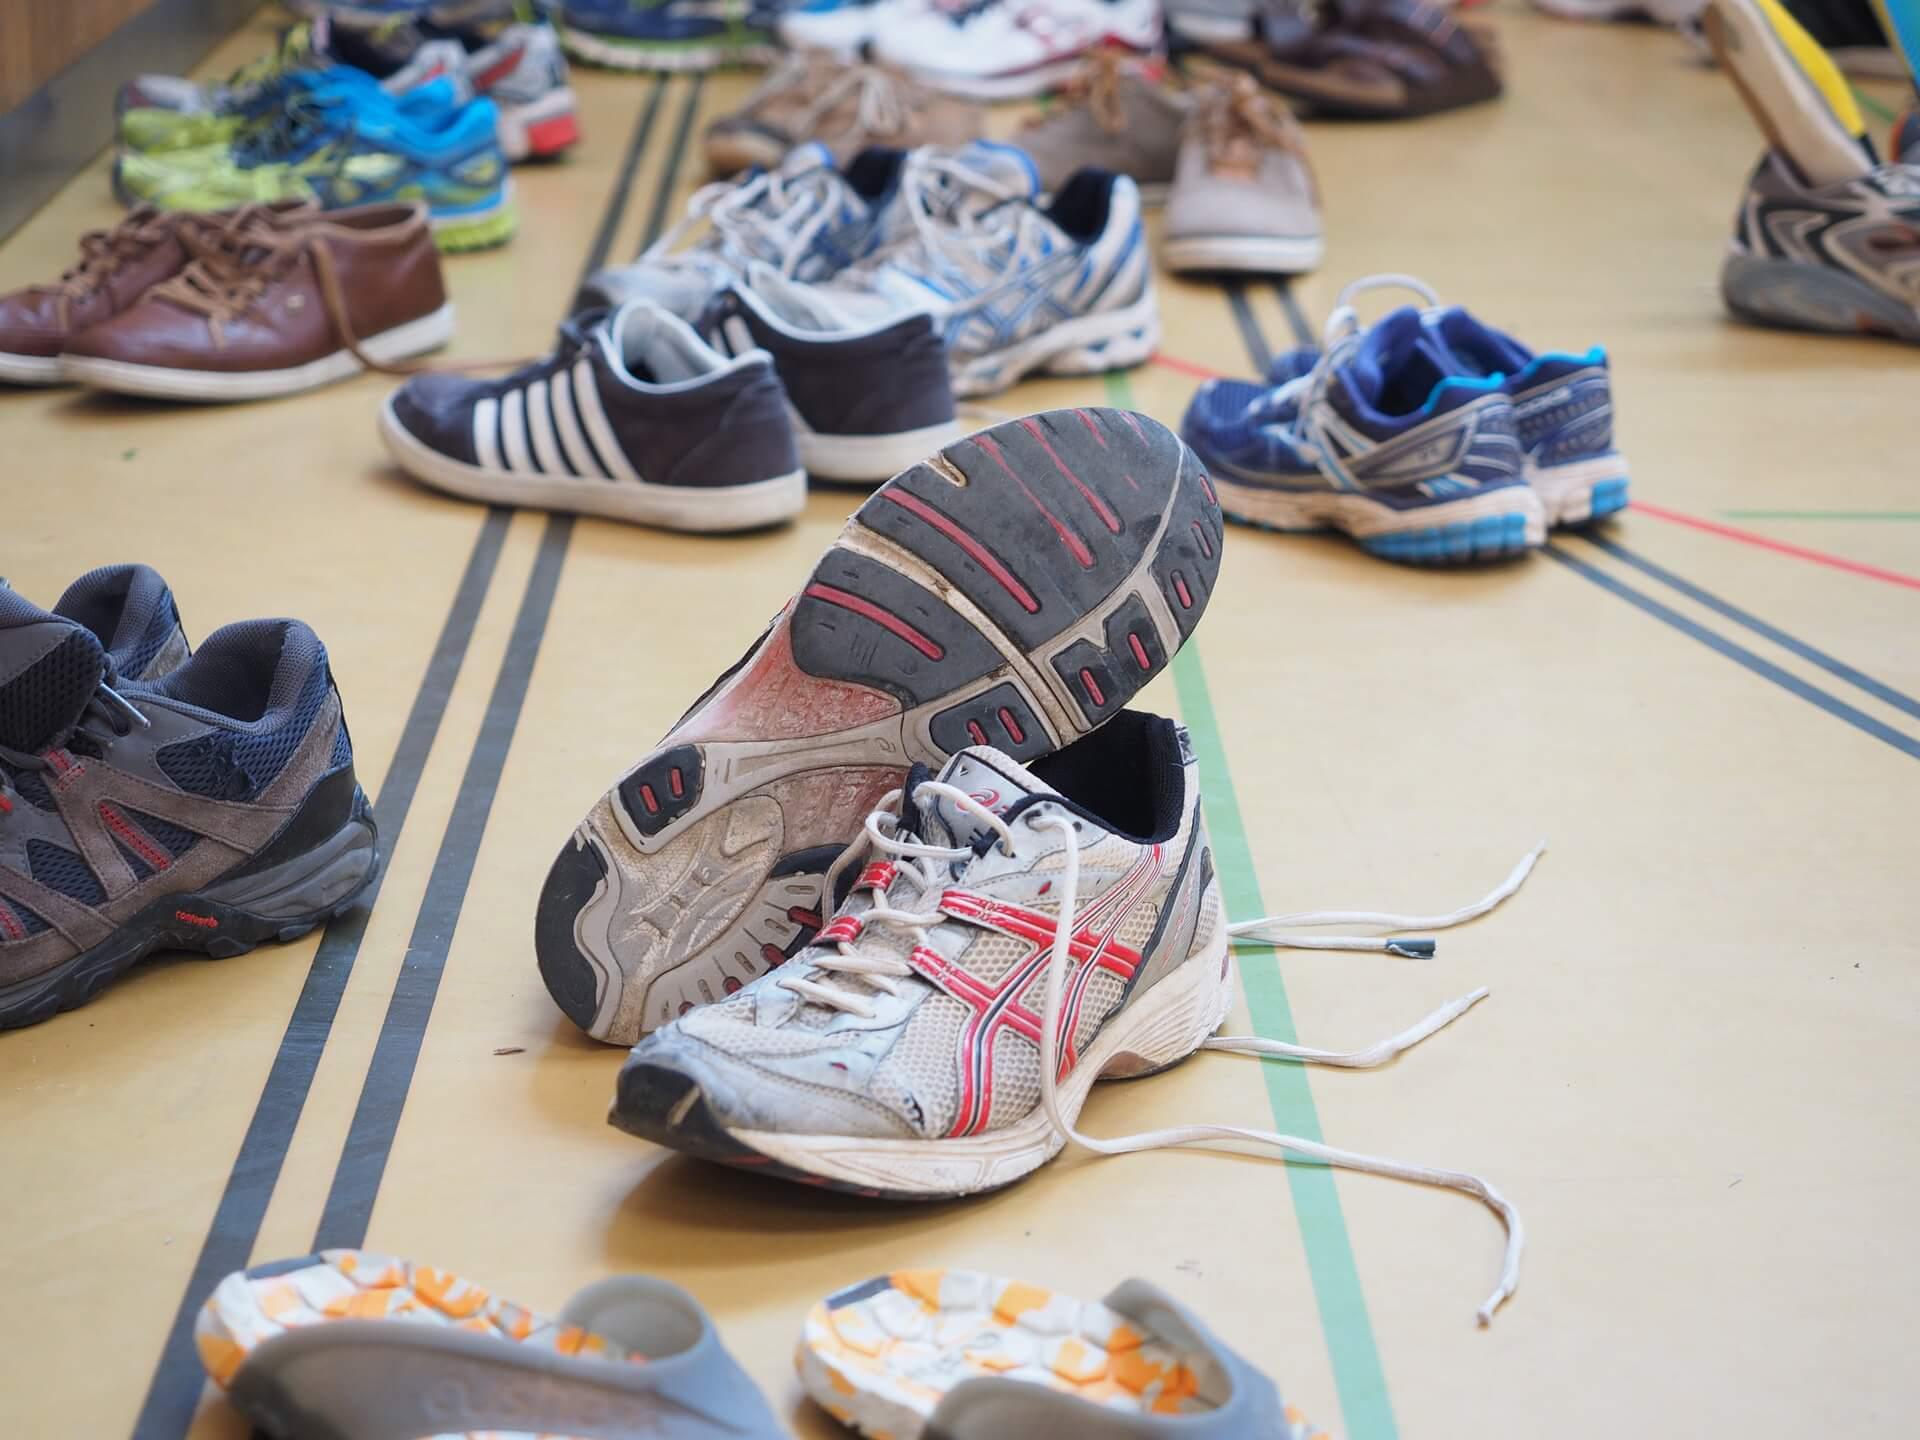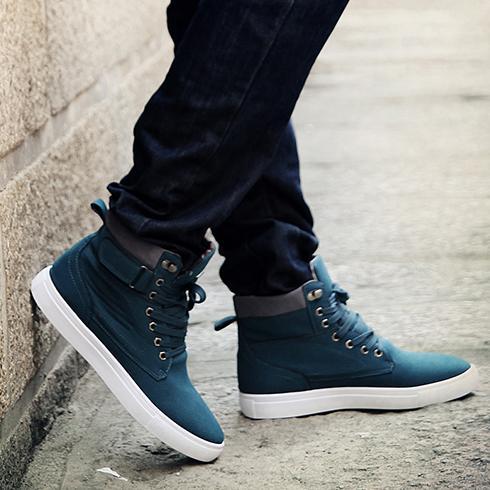The first image is the image on the left, the second image is the image on the right. Evaluate the accuracy of this statement regarding the images: "In one of the images, a pair of shoes with a white sole are modelled by a human.". Is it true? Answer yes or no. Yes. The first image is the image on the left, the second image is the image on the right. For the images shown, is this caption "Someone is wearing the shoes in one of the images." true? Answer yes or no. Yes. 